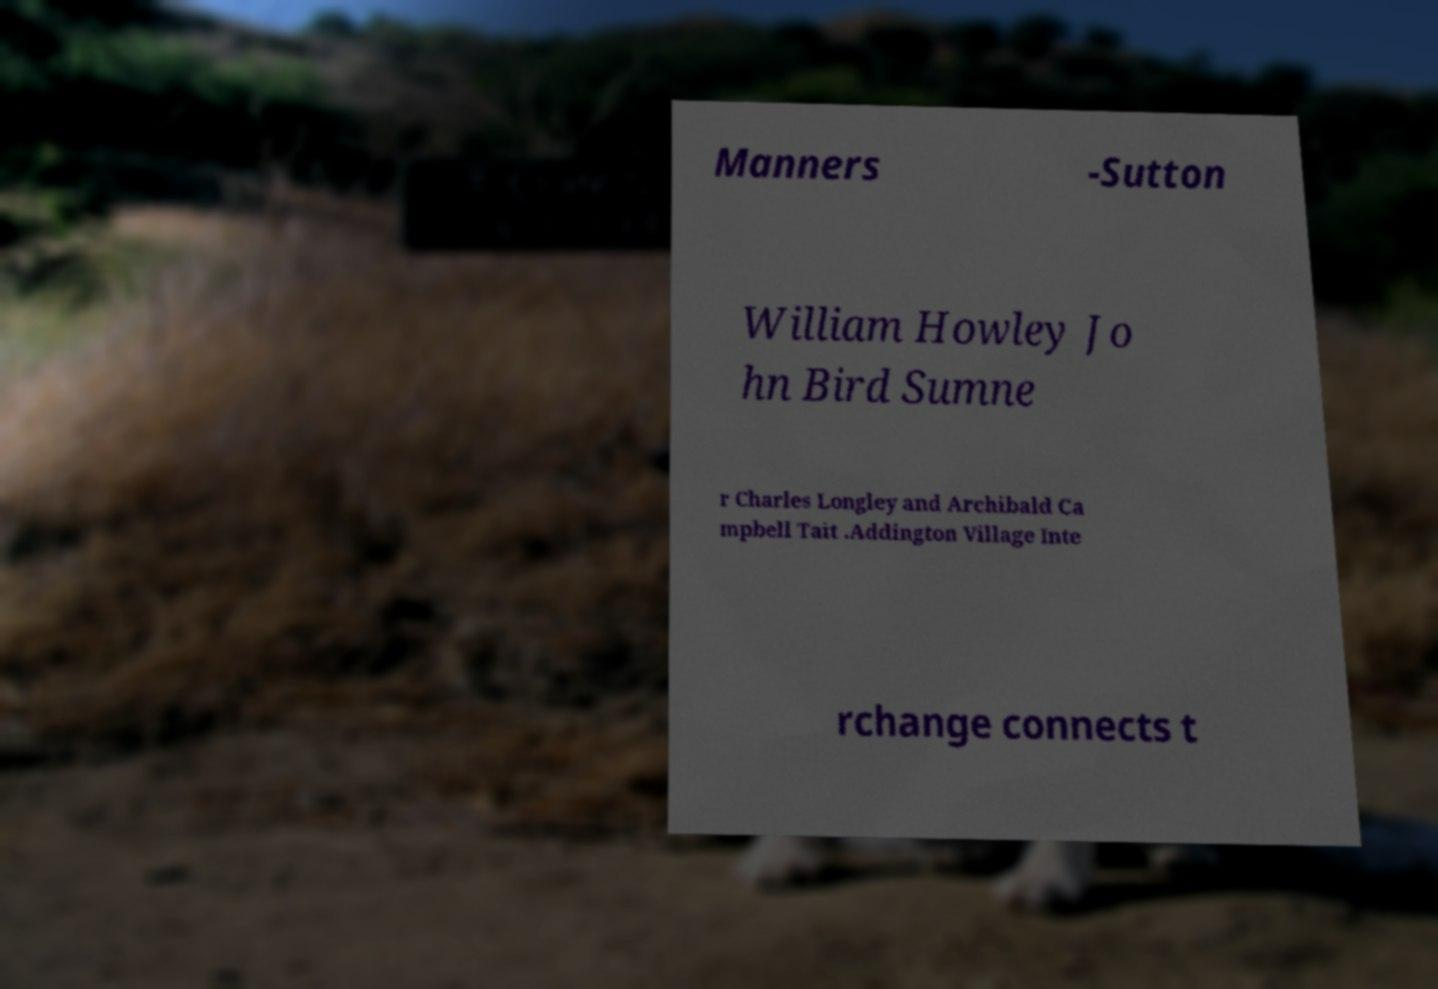I need the written content from this picture converted into text. Can you do that? Manners -Sutton William Howley Jo hn Bird Sumne r Charles Longley and Archibald Ca mpbell Tait .Addington Village Inte rchange connects t 